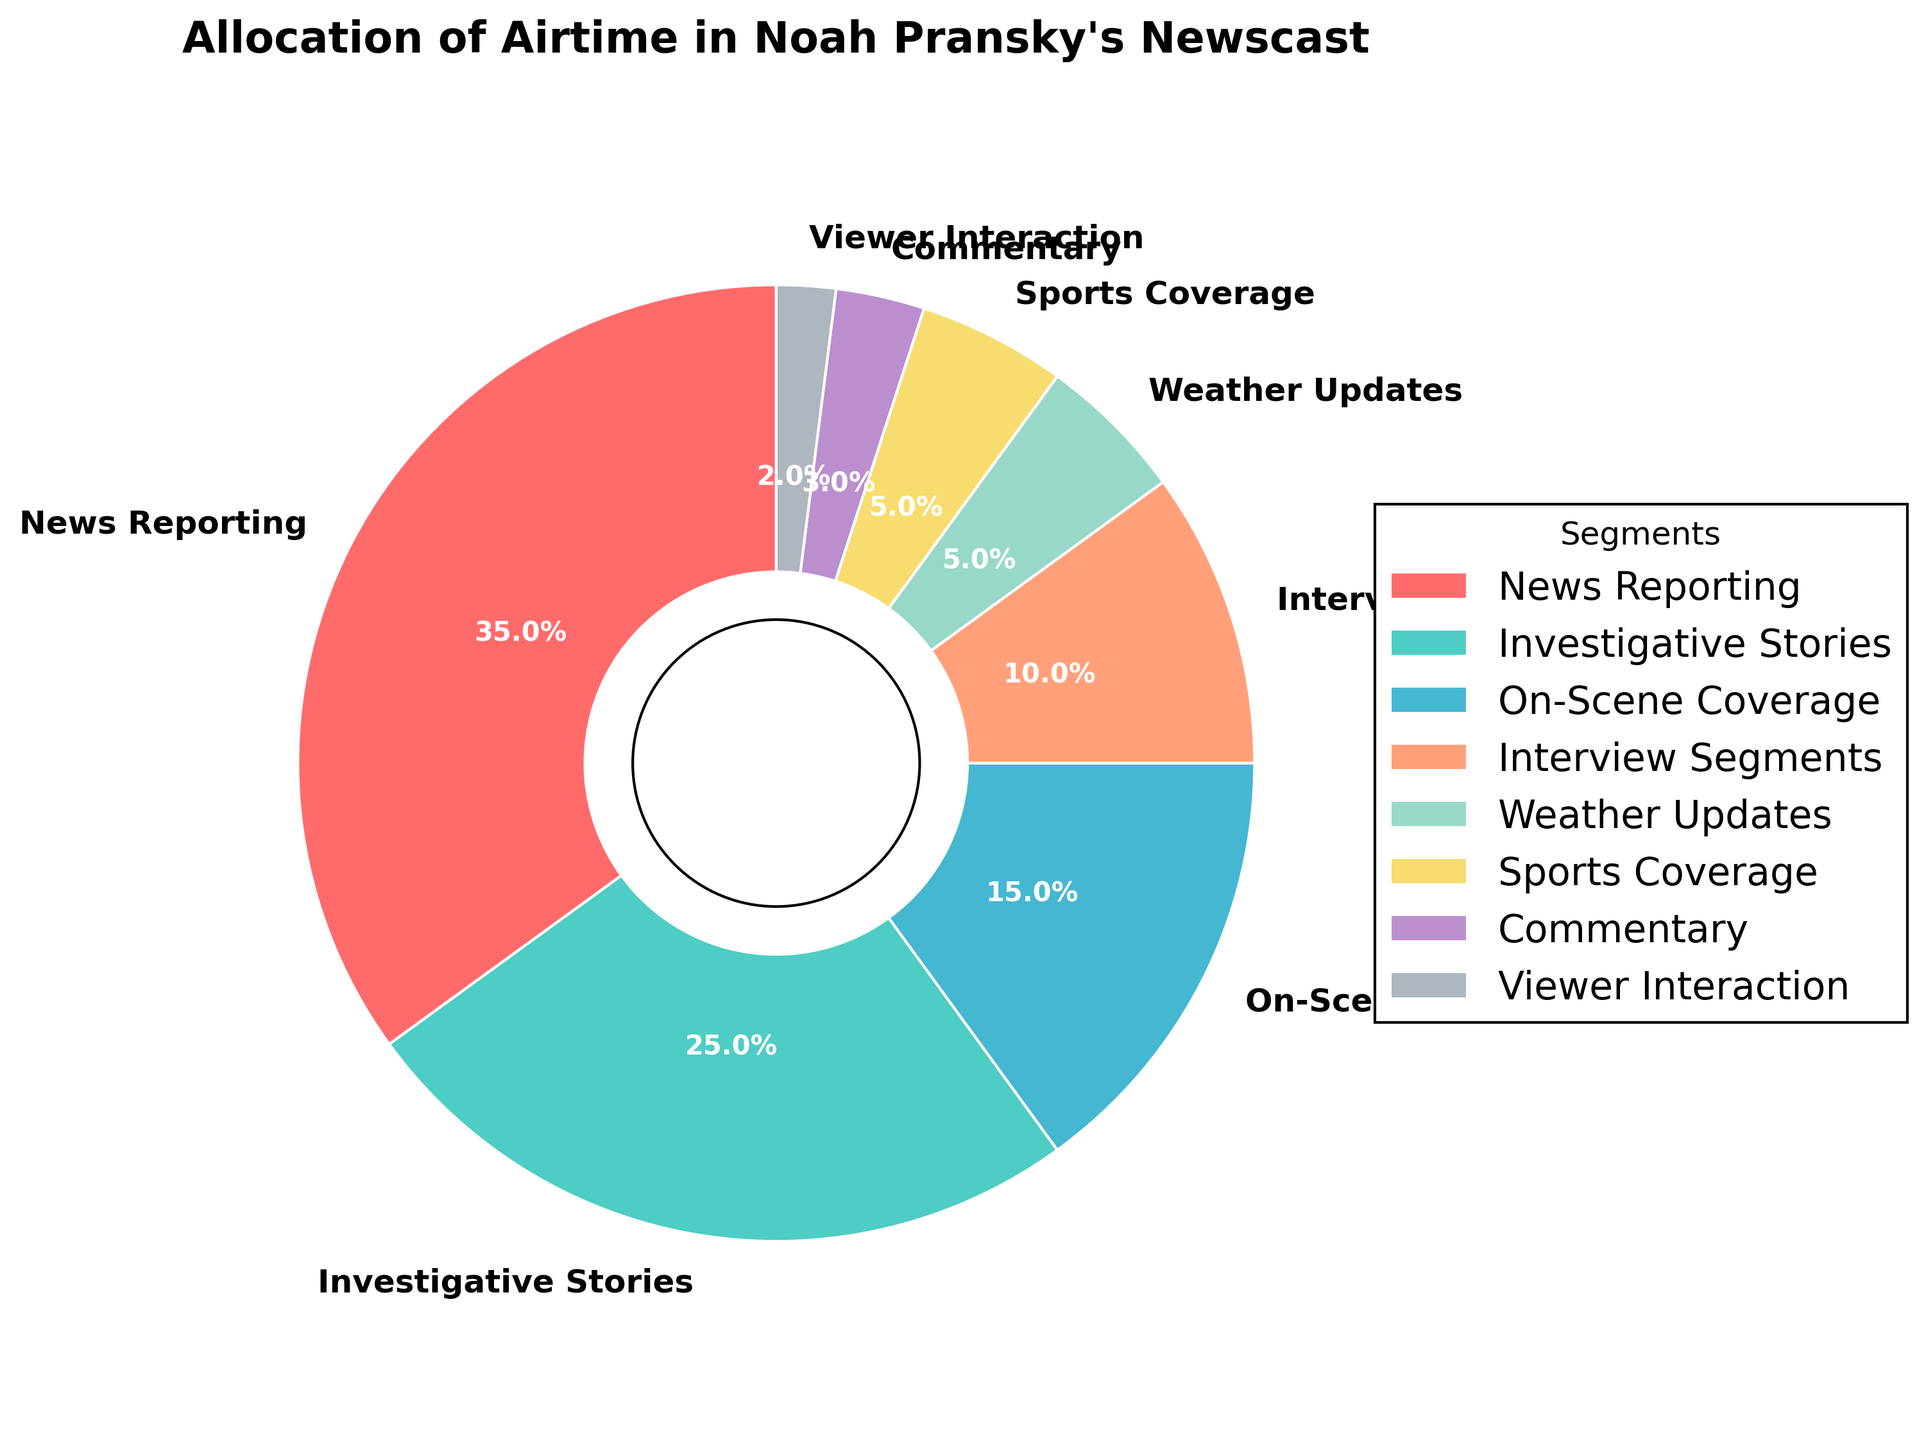How much more airtime is allocated to news reporting compared to on-scene coverage? To find the difference in airtime between news reporting and on-scene coverage, subtract the percentage allocated to on-scene coverage (15%) from that allocated to news reporting (35%). Thus, 35% - 15% = 20%.
Answer: 20% Which segment has the smallest allocation of airtime? Identifying the smallest segment requires examining each segment’s airtime percentage. Viewer Interaction has the smallest allocation at 2%.
Answer: Viewer Interaction What is the total percentage of airtime allocated to investigative stories, interview segments, and sports coverage combined? Add the airtime percentages for the three segments: Investigative Stories (25%), Interview Segments (10%), and Sports Coverage (5%). Hence, 25% + 10% + 5% = 40%.
Answer: 40% Is the airtime for news reporting more than double that for weather updates? Compare the percentage for news reporting (35%) to twice the percentage for weather updates (2 × 5%). Since 35% > 10%, news reporting is more than double that for weather updates.
Answer: Yes What is the percentage difference between investigative stories and commentary? Subtract the percentage of commentary (3%) from the percentage of investigative stories (25%) to find the difference. Thus, 25% - 3% = 22%.
Answer: 22% What color is associated with the sports coverage segment in the pie chart? By analyzing the visual attributes of the pie chart, sports coverage is indicated by the segment colored in gold.
Answer: Gold Which segment uses a cool color in the pie chart, weather updates or commentary? Looking at the color distribution: Weather Updates are teal/blue (cool), and Commentary is purple (warm). Therefore, Weather Updates use a cool color.
Answer: Weather Updates Which two segments together take up 10% of the airtime? Adding Viewer Interaction (2%) and Commentary (3%) does not sum to 10%. The segments that do are Interview Segments (10%) alone, so no pair sums to exactly 10%.
Answer: No pair What is the combined airtime allotment for all segments not involving direct news reporting? Exclude the airtime for News Reporting (35%) from the total remaining airtime. 100% - 35% = 65% is the combined allotment for other segments.
Answer: 65% 